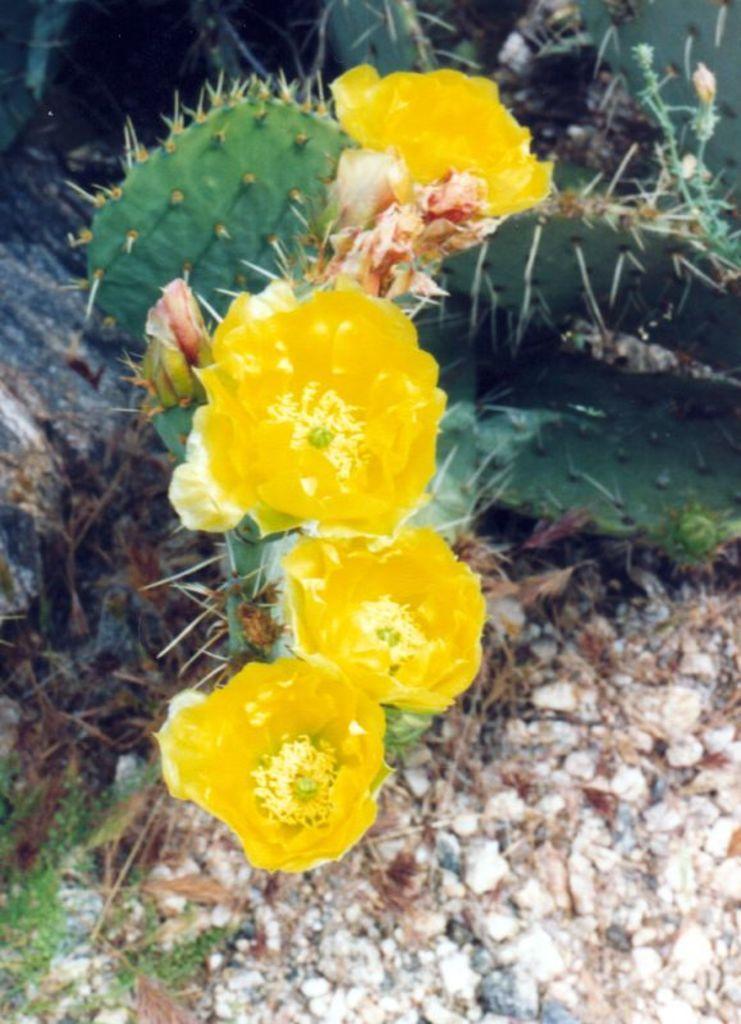How would you summarize this image in a sentence or two? In the image we can see a cactus plant and cactus flowers, the flowers are yellow in color. These are the stones. 